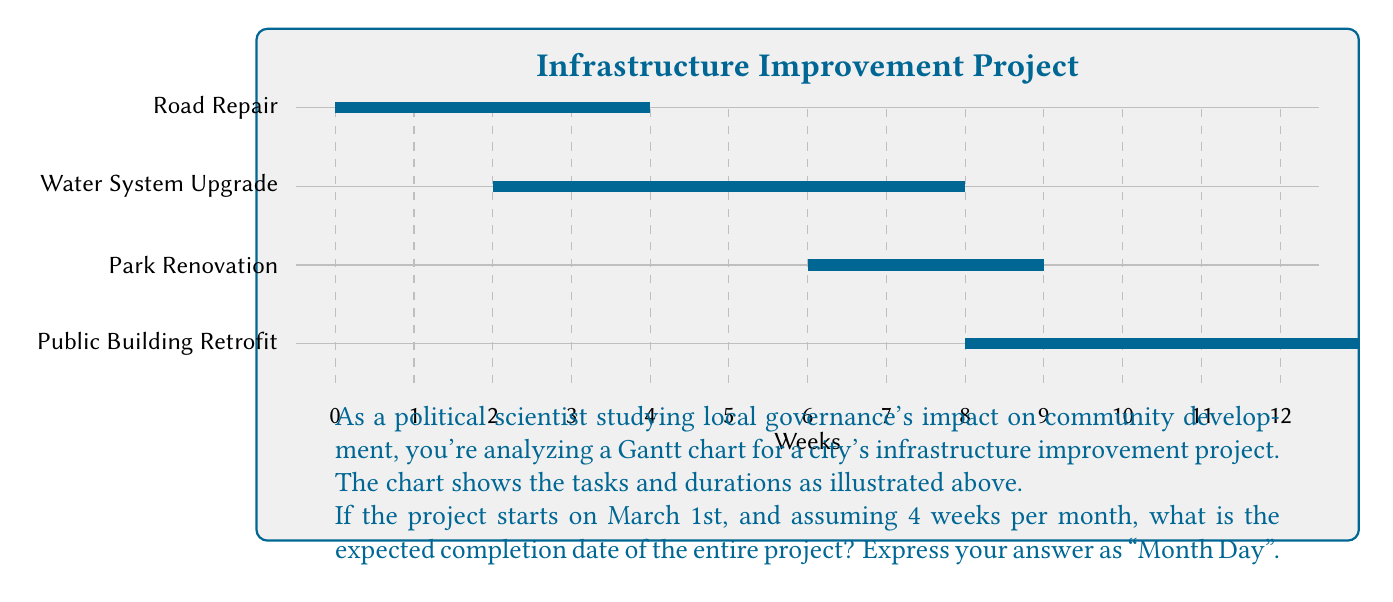Can you answer this question? Let's approach this step-by-step:

1) First, we need to identify the end date of the last task to complete. Looking at the Gantt chart:
   - Road Repair: Starts at week 0, ends at week 4
   - Water System Upgrade: Starts at week 2, ends at week 8
   - Park Renovation: Starts at week 6, ends at week 9
   - Public Building Retrofit: Starts at week 8, ends at week 13

2) The project ends when the last task is completed, which is the Public Building Retrofit at week 13.

3) Now, we need to convert 13 weeks to months and days:
   - We're told there are 4 weeks per month
   - 13 weeks ÷ 4 weeks/month = 3.25 months

4) 0.25 months is equivalent to 1 week (0.25 * 4 = 1)

5) So, the project will end 3 months and 1 week after March 1st

6) Counting forward:
   - March (31 days)
   - April (30 days)
   - May (31 days)
   - 1 week into June (7 days)

7) June 8th is 3 months and 1 week after March 1st

Therefore, the expected completion date is June 8th.
Answer: June 8 